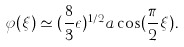<formula> <loc_0><loc_0><loc_500><loc_500>\varphi ( \xi ) \simeq ( \frac { 8 } { 3 } \epsilon ) ^ { 1 / 2 } a \cos ( \frac { \pi } { 2 } \xi ) .</formula> 